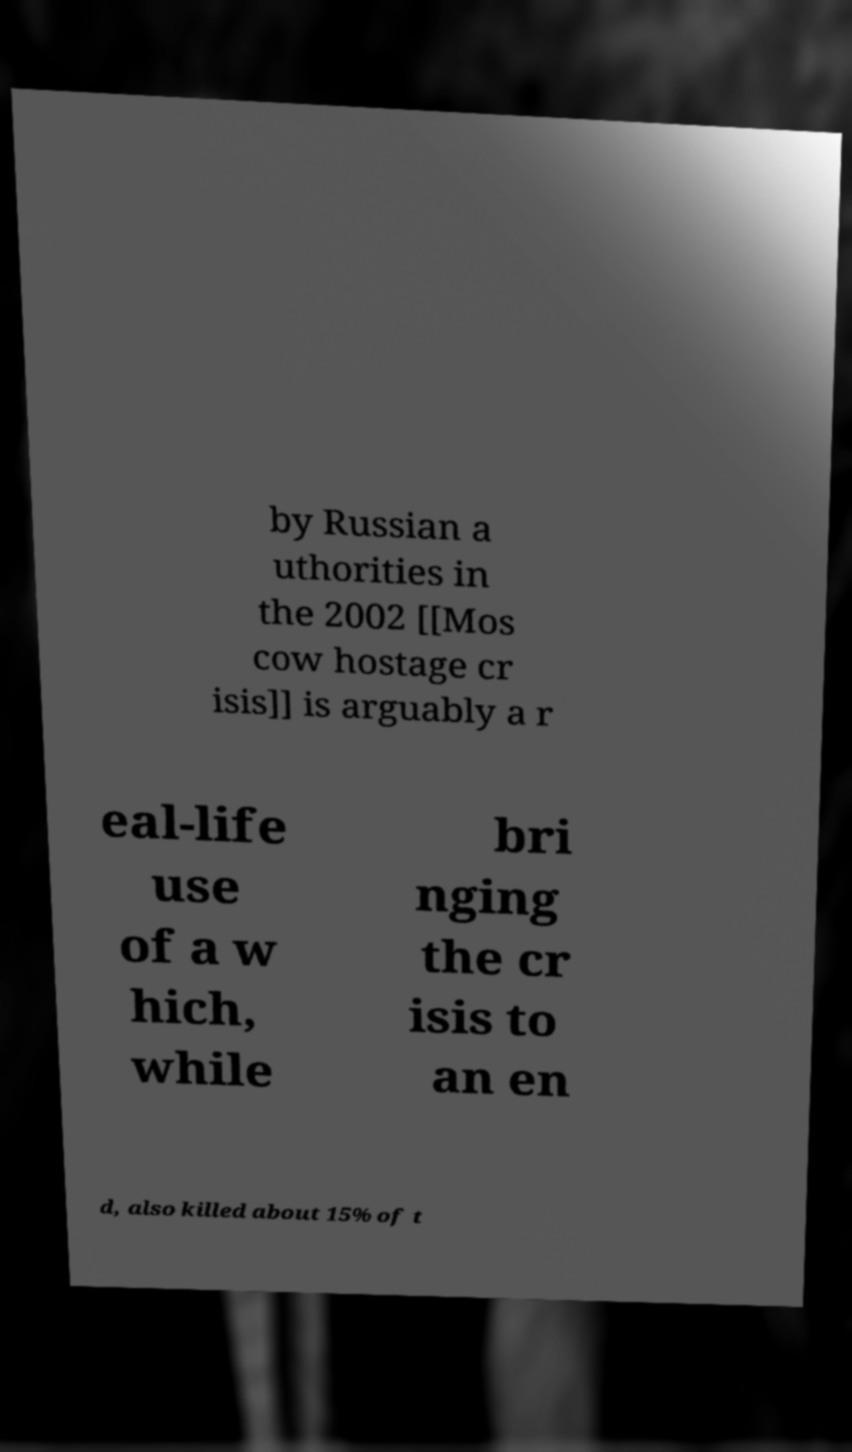Please identify and transcribe the text found in this image. by Russian a uthorities in the 2002 [[Mos cow hostage cr isis]] is arguably a r eal-life use of a w hich, while bri nging the cr isis to an en d, also killed about 15% of t 